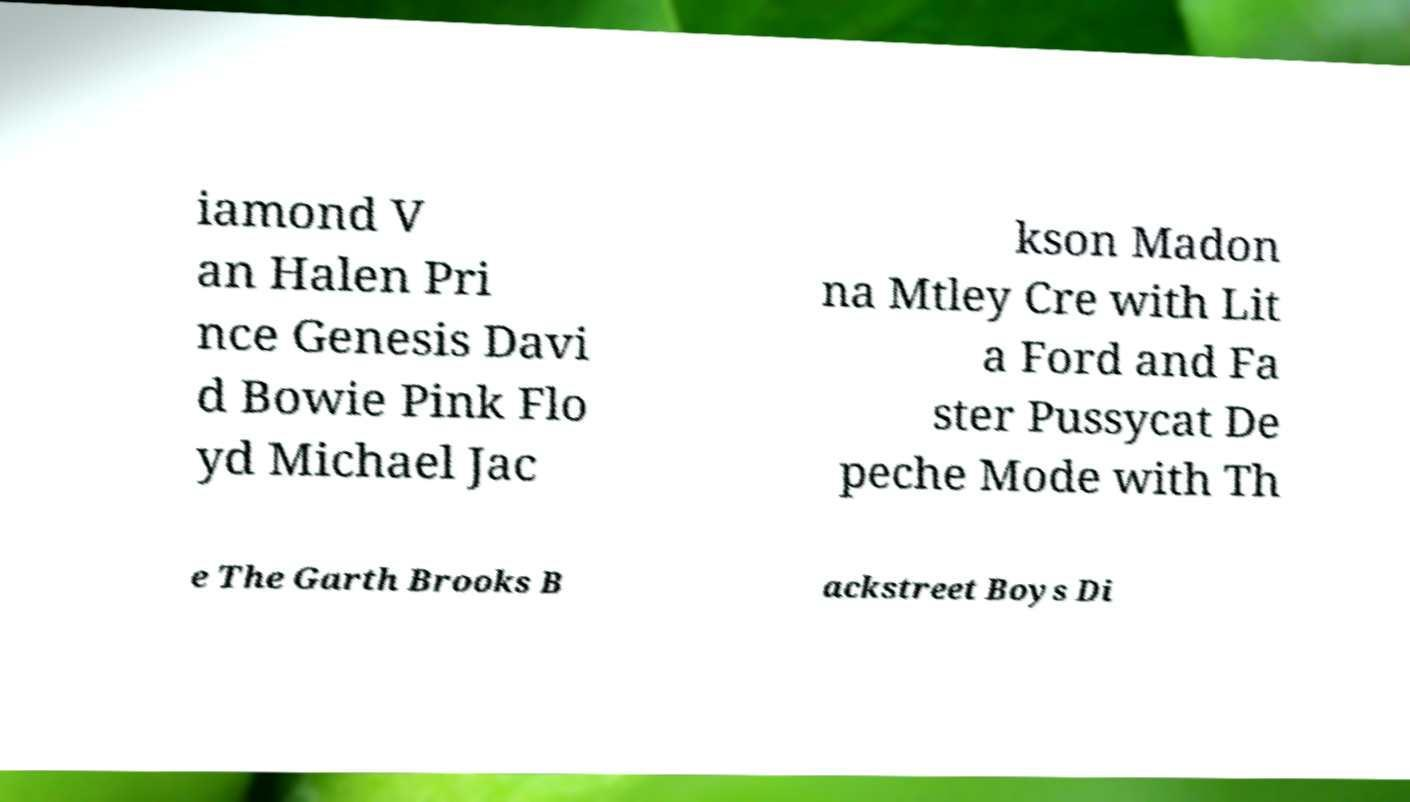There's text embedded in this image that I need extracted. Can you transcribe it verbatim? iamond V an Halen Pri nce Genesis Davi d Bowie Pink Flo yd Michael Jac kson Madon na Mtley Cre with Lit a Ford and Fa ster Pussycat De peche Mode with Th e The Garth Brooks B ackstreet Boys Di 